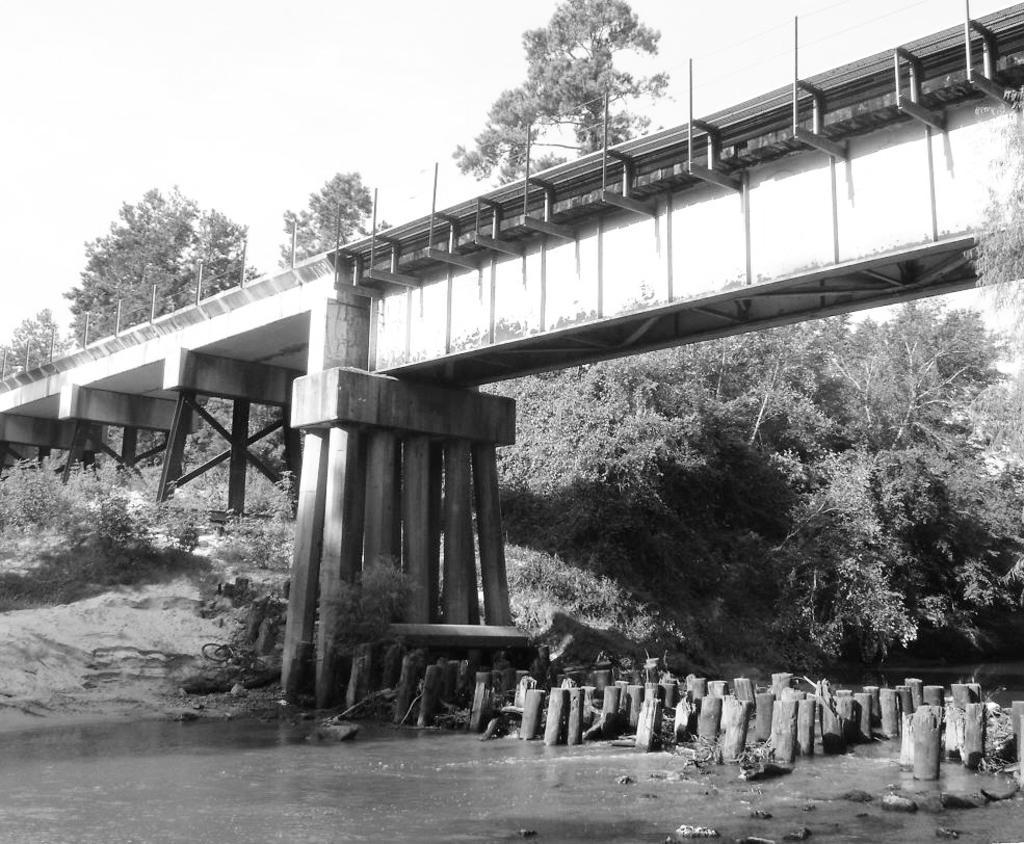In one or two sentences, can you explain what this image depicts? This is a black and white picture. Here we can see a bridgewater, small poles, ground, plants, and trees. In the background there is sky. 